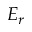Convert formula to latex. <formula><loc_0><loc_0><loc_500><loc_500>E _ { r }</formula> 